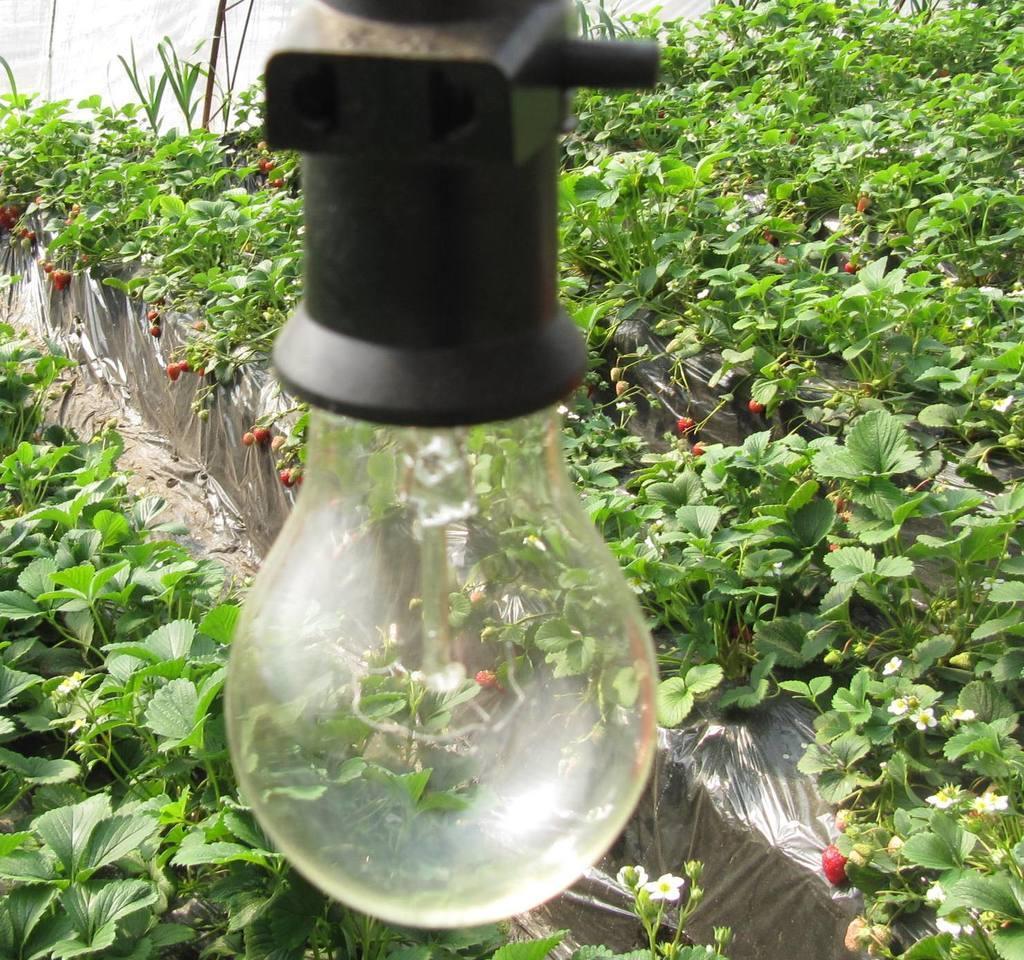In one or two sentences, can you explain what this image depicts? In this image I can see a bulb. I can also see green color leaves and few red colour things in background. 